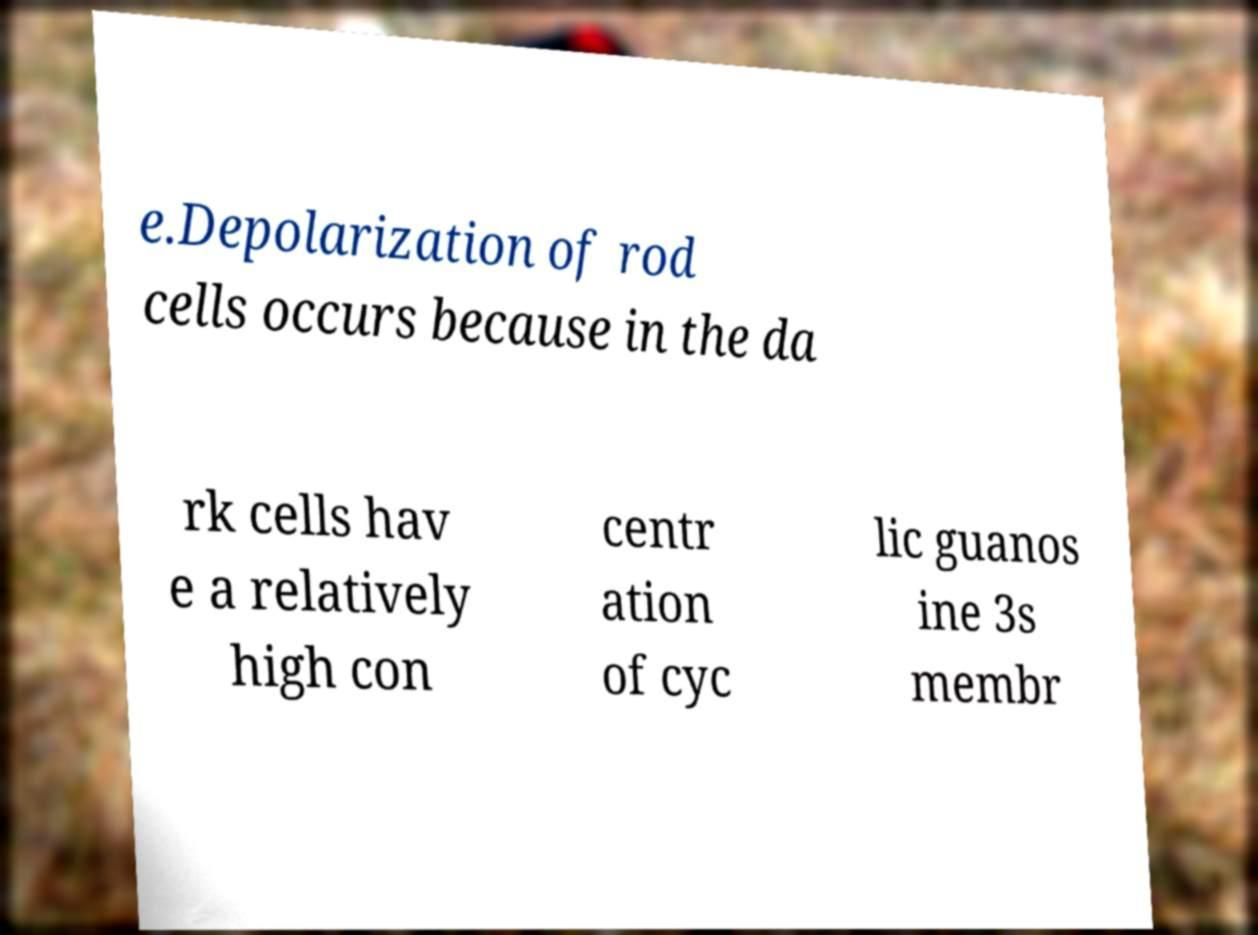There's text embedded in this image that I need extracted. Can you transcribe it verbatim? e.Depolarization of rod cells occurs because in the da rk cells hav e a relatively high con centr ation of cyc lic guanos ine 3s membr 